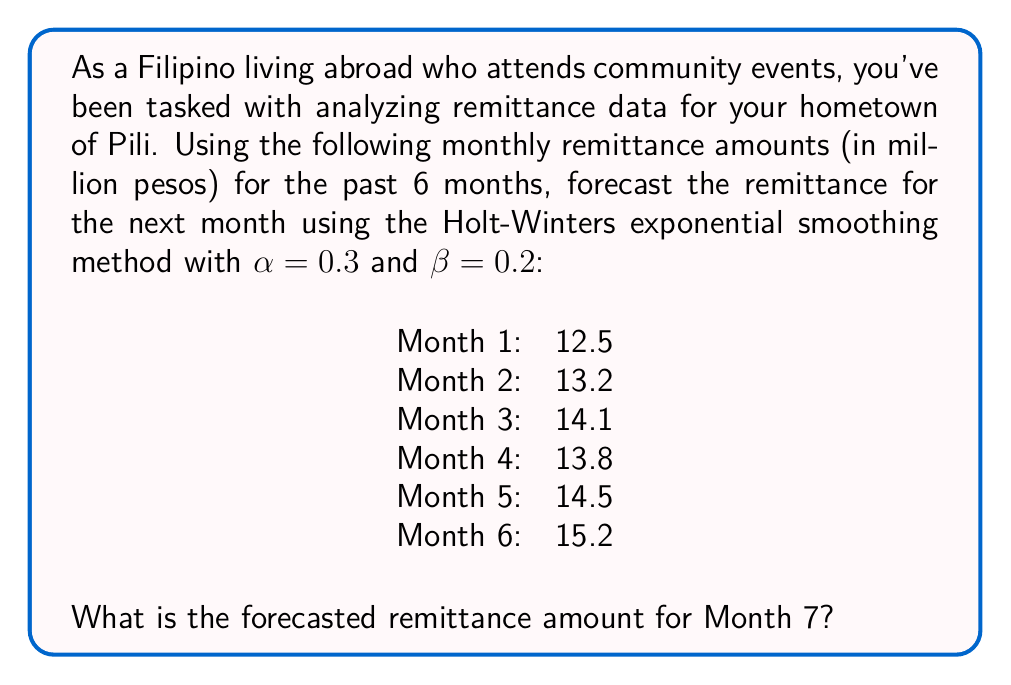Teach me how to tackle this problem. To solve this problem, we'll use the Holt-Winters exponential smoothing method without seasonality (also known as double exponential smoothing). This method is suitable for time series data with a trend but no seasonal component.

The Holt-Winters method uses two equations:

1. Level equation: $L_t = \alpha Y_t + (1-\alpha)(L_{t-1} + T_{t-1})$
2. Trend equation: $T_t = \beta(L_t - L_{t-1}) + (1-\beta)T_{t-1}$

Where:
$L_t$ is the level at time t
$T_t$ is the trend at time t
$Y_t$ is the observed value at time t
$\alpha$ is the level smoothing factor (given as 0.3)
$\beta$ is the trend smoothing factor (given as 0.2)

To start, we need initial values for $L_0$ and $T_0$:
$L_0 = Y_1 = 12.5$
$T_0 = Y_2 - Y_1 = 13.2 - 12.5 = 0.7$

Now, let's calculate the level and trend for each month:

Month 1:
$L_1 = 0.3(12.5) + (1-0.3)(12.5 + 0.7) = 12.74$
$T_1 = 0.2(12.74 - 12.5) + (1-0.2)(0.7) = 0.608$

Month 2:
$L_2 = 0.3(13.2) + (1-0.3)(12.74 + 0.608) = 13.2452$
$T_2 = 0.2(13.2452 - 12.74) + (1-0.2)(0.608) = 0.6066$

Month 3:
$L_3 = 0.3(14.1) + (1-0.3)(13.2452 + 0.6066) = 13.77364$
$T_3 = 0.2(13.77364 - 13.2452) + (1-0.2)(0.6066) = 0.61468$

Month 4:
$L_4 = 0.3(13.8) + (1-0.3)(13.77364 + 0.61468) = 13.95881$
$T_4 = 0.2(13.95881 - 13.77364) + (1-0.2)(0.61468) = 0.59792$

Month 5:
$L_5 = 0.3(14.5) + (1-0.3)(13.95881 + 0.59792) = 14.35572$
$T_5 = 0.2(14.35572 - 13.95881) + (1-0.2)(0.59792) = 0.60078$

Month 6:
$L_6 = 0.3(15.2) + (1-0.3)(14.35572 + 0.60078) = 14.86955$
$T_6 = 0.2(14.86955 - 14.35572) + (1-0.2)(0.60078) = 0.62355$

Now, we can forecast Month 7 using the formula:
$F_{t+1} = L_t + T_t$

$F_7 = L_6 + T_6 = 14.86955 + 0.62355 = 15.4931$
Answer: The forecasted remittance amount for Month 7 is approximately 15.49 million pesos. 